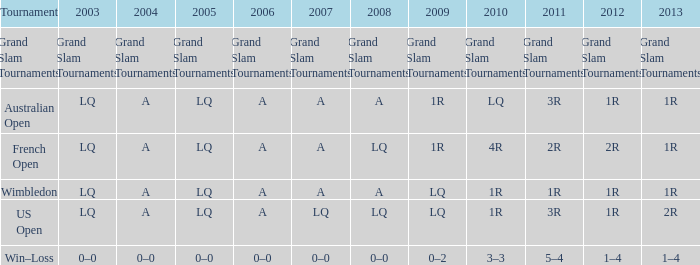Which year has a 2011 of 1r? A. 